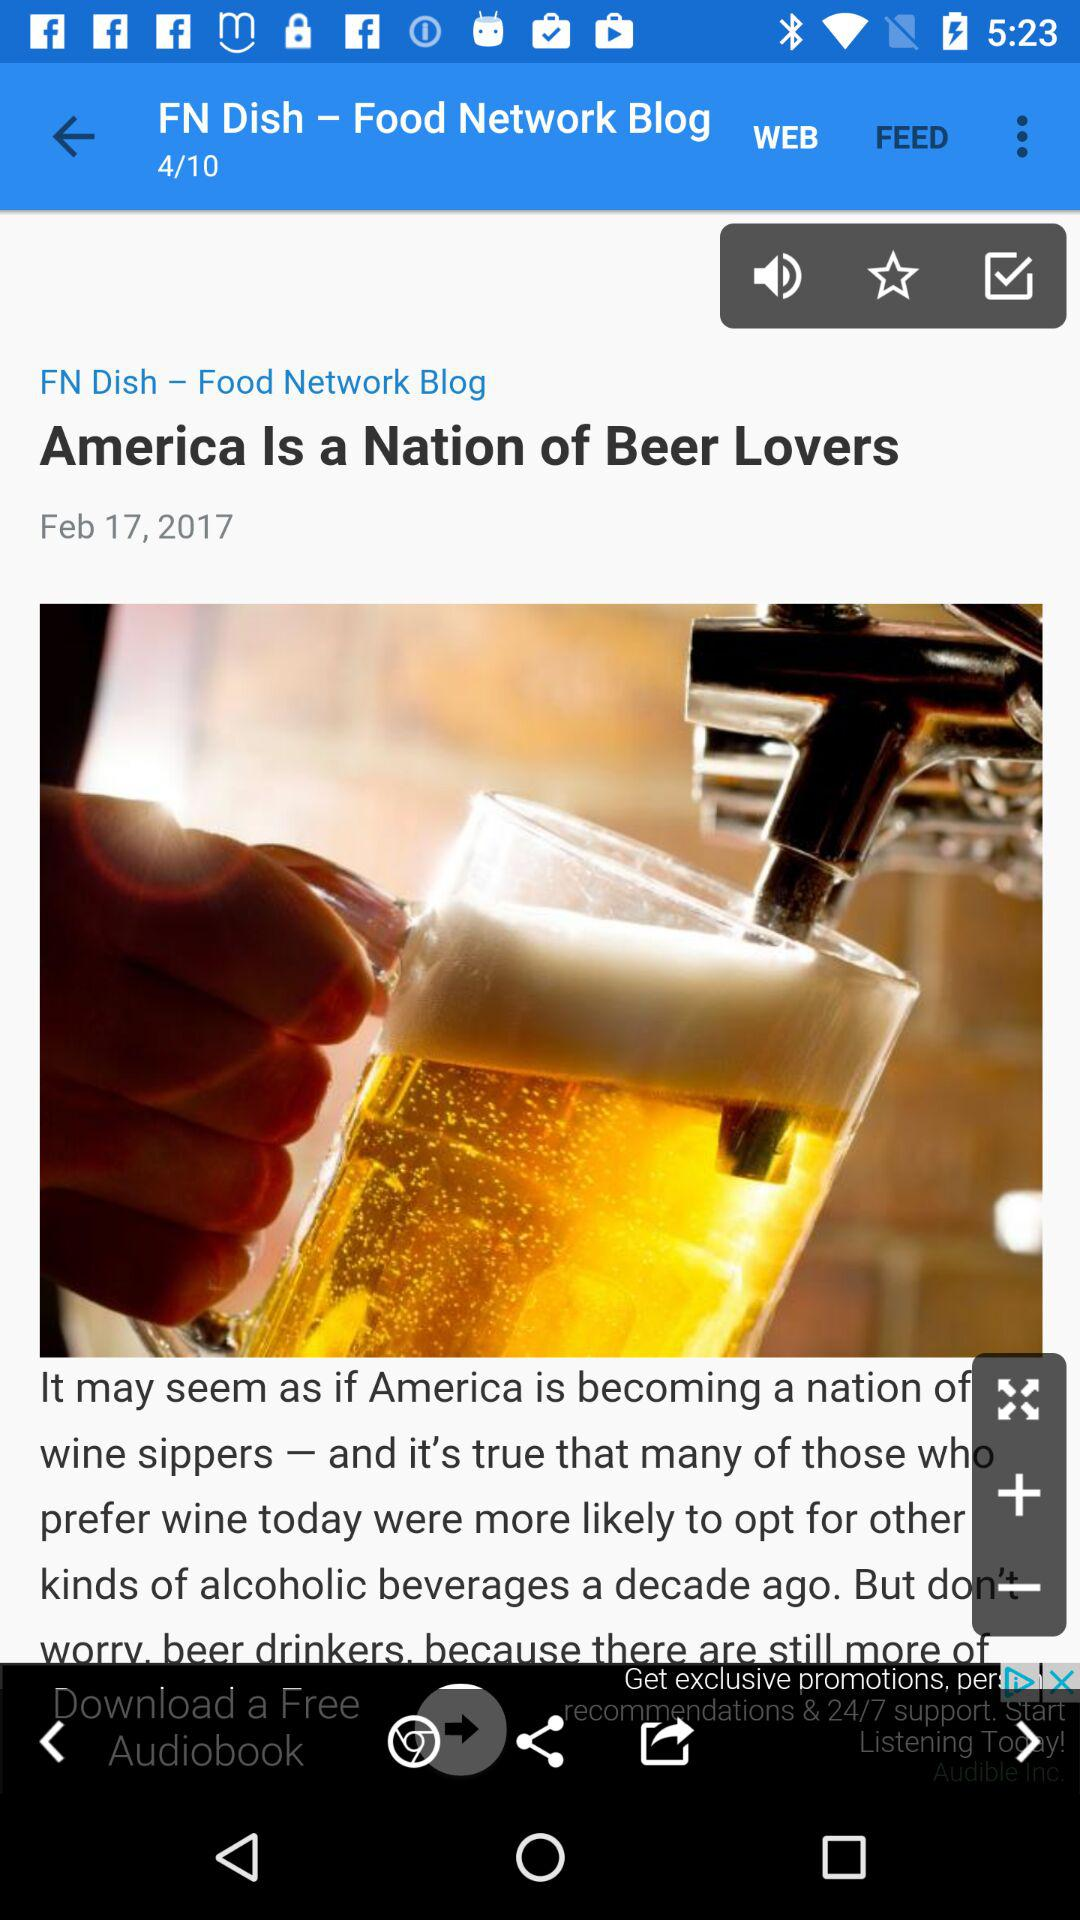When was the article "America Is a Nation of Beer Lovers" published? The article "America Is a Nation of Beer Lovers" was published on February 17, 2017. 